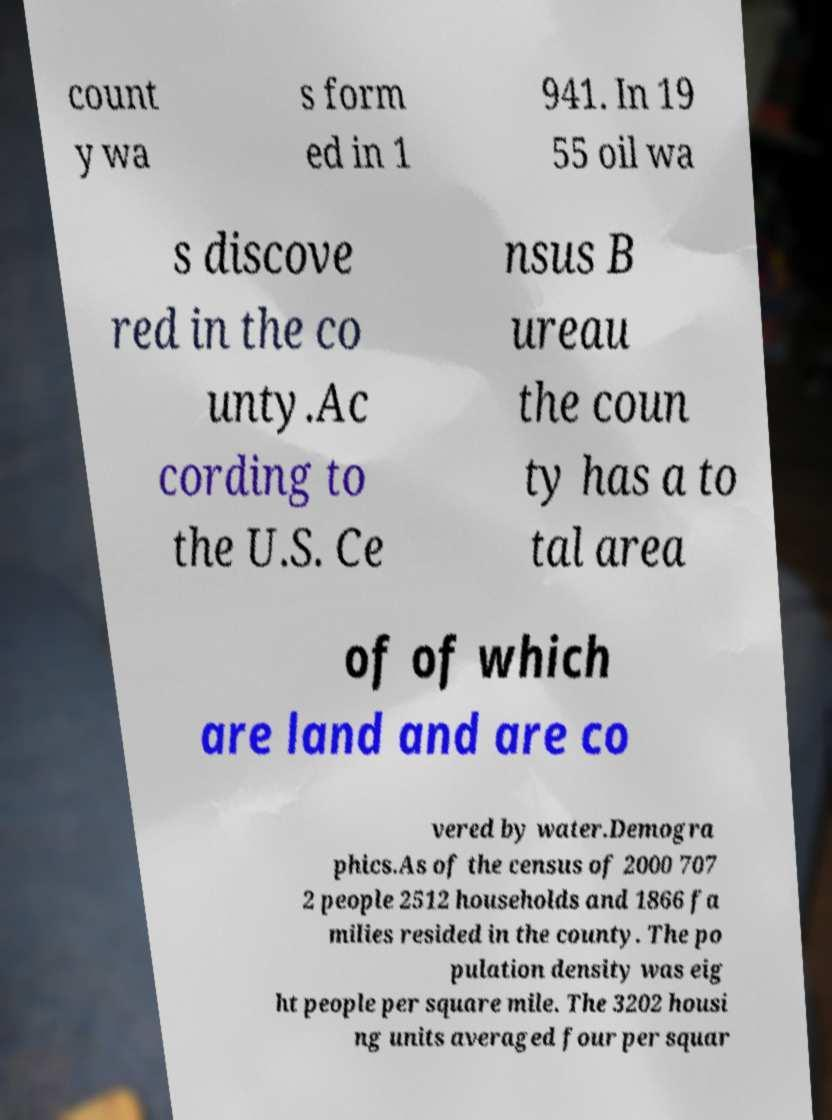For documentation purposes, I need the text within this image transcribed. Could you provide that? count y wa s form ed in 1 941. In 19 55 oil wa s discove red in the co unty.Ac cording to the U.S. Ce nsus B ureau the coun ty has a to tal area of of which are land and are co vered by water.Demogra phics.As of the census of 2000 707 2 people 2512 households and 1866 fa milies resided in the county. The po pulation density was eig ht people per square mile. The 3202 housi ng units averaged four per squar 